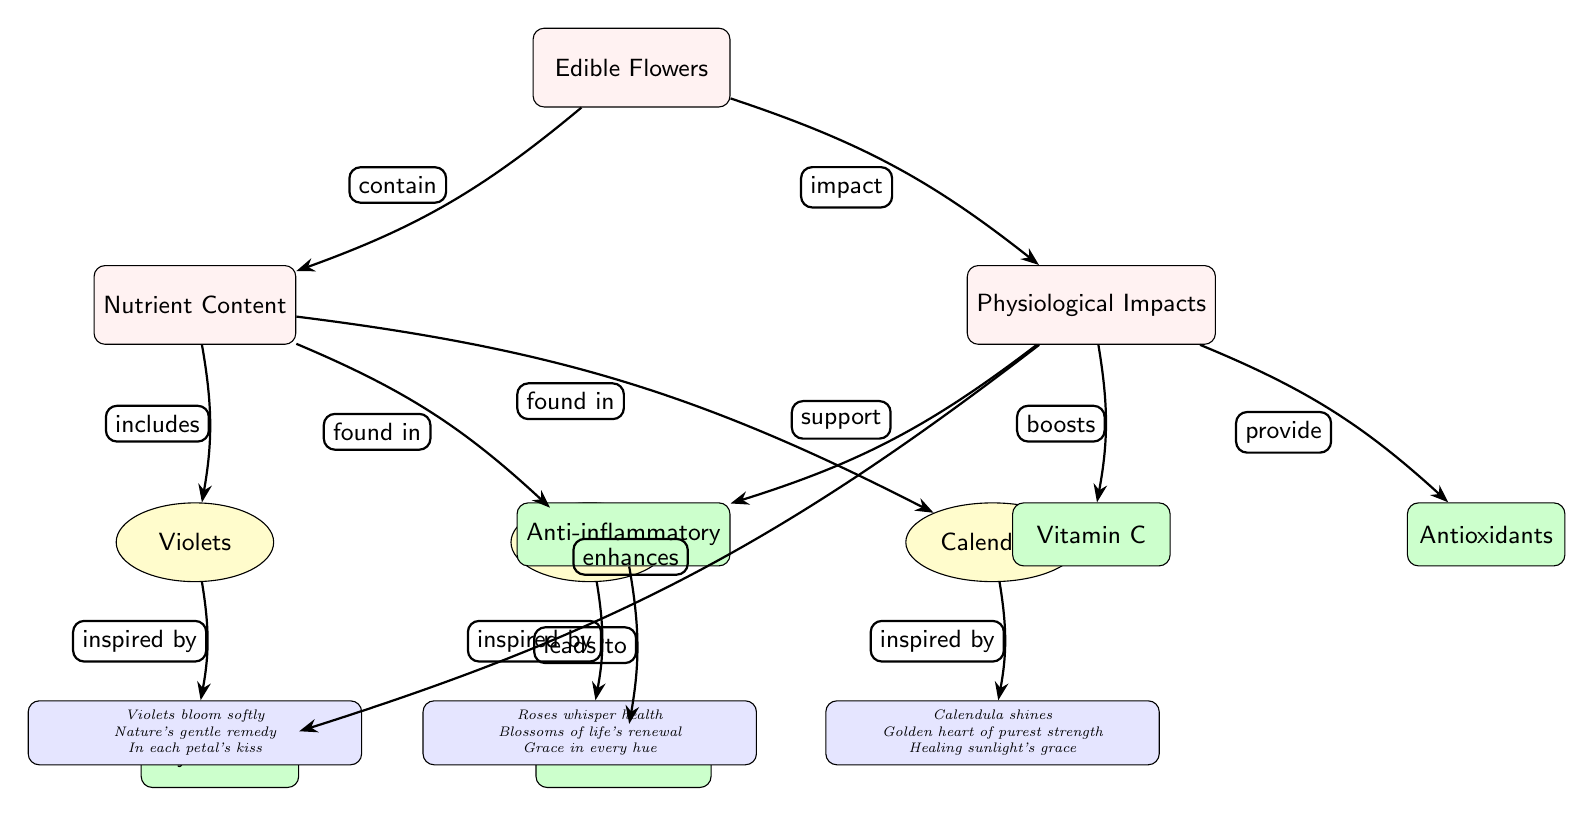What type of diagram is represented here? The diagram showcases a flow structure outlining the comparative health benefits of edible flowers, making it a biomedical diagram focused on nutrient content and physiological impacts.
Answer: Biomedical Diagram How many types of edible flowers are listed? The diagram mentions three specific types of edible flowers: violets, roses, and calendula, indicating the variety represented in terms of their health benefits.
Answer: Three What health benefit is connected to anti-inflammatory effects? The diagram shows that the anti-inflammatory effects lead to an immune boost as a direct physiological impact of consuming edible flowers.
Answer: Immune Boost Which flower is associated with the haiku mentioning healing sunlight's grace? The haiku mentioning healing sunlight's grace is associated with calendula, which is highlighted as having a golden heart of purest strength.
Answer: Calendula What nutrient is explicitly mentioned in the diagram as part of the physiological impacts? The diagram lists Vitamin C as one of the nutrients affected by the consumption of edible flowers, showcasing its health benefits.
Answer: Vitamin C What relationship do roses have with the nutrient content? Roses are noted to be found in the nutrient content section of the diagram, indicating their role in contributing to the nutritional benefits of edible flowers.
Answer: Found in Which flower contributes to eye health, according to the diagram? The diagram indicates that the benefits stemming from the consumption of edible flowers enhance eye health, although it does not specify which flower contributes this directly. However, the context suggests it is an overall benefit derived from the variety of flowers listed.
Answer: Eye Health How many edges are connecting the flowers to the nutrient content? There are three edges connecting the three listed flowers—violets, roses, and calendula—to the nutrient content, illustrating each flower's contribution.
Answer: Three Which flower is represented with a haiku that reflects nature's gentle remedy? The violets are represented with the haiku reflecting nature's gentle remedy, capturing the essence of their delicacy and health benefits.
Answer: Violets 